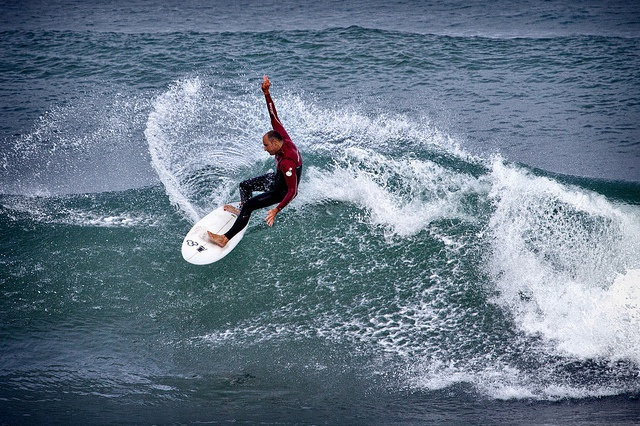Describe the objects in this image and their specific colors. I can see people in navy, black, maroon, brown, and gray tones and surfboard in navy, white, darkgray, and gray tones in this image. 